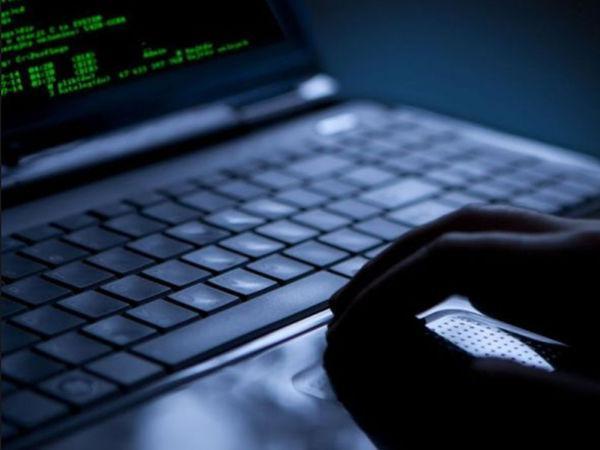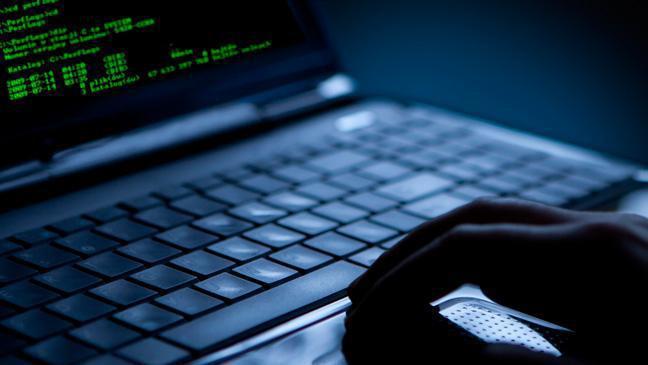The first image is the image on the left, the second image is the image on the right. Considering the images on both sides, is "A light source is attached to a laptop" valid? Answer yes or no. No. The first image is the image on the left, the second image is the image on the right. Evaluate the accuracy of this statement regarding the images: "In 1 of the images, 2 hands are typing.". Is it true? Answer yes or no. No. 